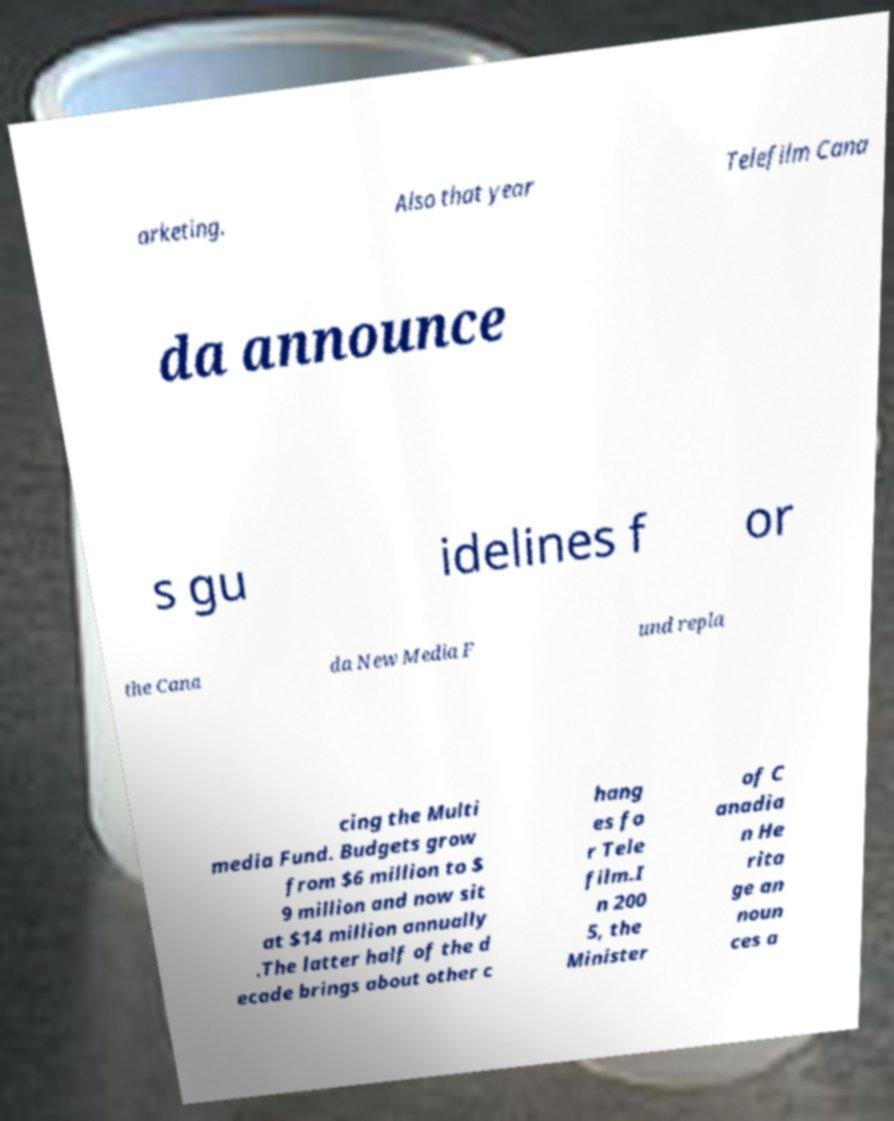Could you extract and type out the text from this image? arketing. Also that year Telefilm Cana da announce s gu idelines f or the Cana da New Media F und repla cing the Multi media Fund. Budgets grow from $6 million to $ 9 million and now sit at $14 million annually .The latter half of the d ecade brings about other c hang es fo r Tele film.I n 200 5, the Minister of C anadia n He rita ge an noun ces a 